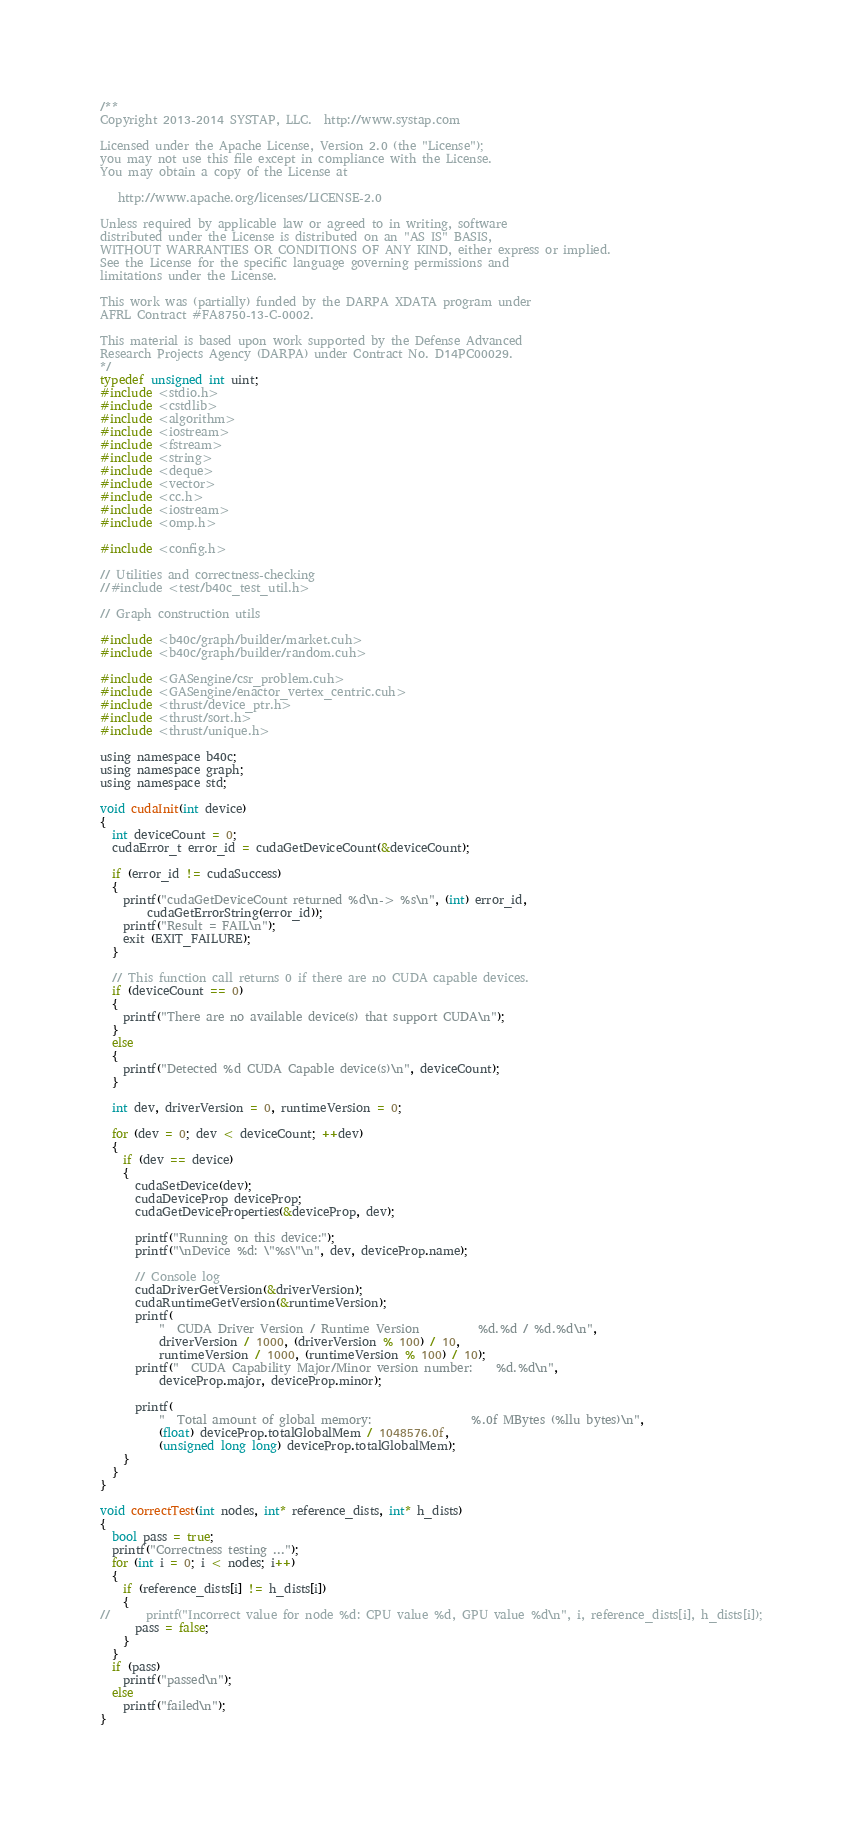Convert code to text. <code><loc_0><loc_0><loc_500><loc_500><_Cuda_>/**
Copyright 2013-2014 SYSTAP, LLC.  http://www.systap.com

Licensed under the Apache License, Version 2.0 (the "License");
you may not use this file except in compliance with the License.
You may obtain a copy of the License at

   http://www.apache.org/licenses/LICENSE-2.0

Unless required by applicable law or agreed to in writing, software
distributed under the License is distributed on an "AS IS" BASIS,
WITHOUT WARRANTIES OR CONDITIONS OF ANY KIND, either express or implied.
See the License for the specific language governing permissions and
limitations under the License.

This work was (partially) funded by the DARPA XDATA program under
AFRL Contract #FA8750-13-C-0002.

This material is based upon work supported by the Defense Advanced
Research Projects Agency (DARPA) under Contract No. D14PC00029.
*/
typedef unsigned int uint;
#include <stdio.h>
#include <cstdlib>
#include <algorithm>
#include <iostream>
#include <fstream>
#include <string>
#include <deque>
#include <vector>
#include <cc.h>
#include <iostream>
#include <omp.h>

#include <config.h>

// Utilities and correctness-checking
//#include <test/b40c_test_util.h>

// Graph construction utils

#include <b40c/graph/builder/market.cuh>
#include <b40c/graph/builder/random.cuh>

#include <GASengine/csr_problem.cuh>
#include <GASengine/enactor_vertex_centric.cuh>
#include <thrust/device_ptr.h>
#include <thrust/sort.h>
#include <thrust/unique.h>

using namespace b40c;
using namespace graph;
using namespace std;

void cudaInit(int device)
{
  int deviceCount = 0;
  cudaError_t error_id = cudaGetDeviceCount(&deviceCount);

  if (error_id != cudaSuccess)
  {
    printf("cudaGetDeviceCount returned %d\n-> %s\n", (int) error_id,
        cudaGetErrorString(error_id));
    printf("Result = FAIL\n");
    exit (EXIT_FAILURE);
  }

  // This function call returns 0 if there are no CUDA capable devices.
  if (deviceCount == 0)
  {
    printf("There are no available device(s) that support CUDA\n");
  }
  else
  {
    printf("Detected %d CUDA Capable device(s)\n", deviceCount);
  }

  int dev, driverVersion = 0, runtimeVersion = 0;

  for (dev = 0; dev < deviceCount; ++dev)
  {
    if (dev == device)
    {
      cudaSetDevice(dev);
      cudaDeviceProp deviceProp;
      cudaGetDeviceProperties(&deviceProp, dev);

      printf("Running on this device:");
      printf("\nDevice %d: \"%s\"\n", dev, deviceProp.name);

      // Console log
      cudaDriverGetVersion(&driverVersion);
      cudaRuntimeGetVersion(&runtimeVersion);
      printf(
          "  CUDA Driver Version / Runtime Version          %d.%d / %d.%d\n",
          driverVersion / 1000, (driverVersion % 100) / 10,
          runtimeVersion / 1000, (runtimeVersion % 100) / 10);
      printf("  CUDA Capability Major/Minor version number:    %d.%d\n",
          deviceProp.major, deviceProp.minor);

      printf(
          "  Total amount of global memory:                 %.0f MBytes (%llu bytes)\n",
          (float) deviceProp.totalGlobalMem / 1048576.0f,
          (unsigned long long) deviceProp.totalGlobalMem);
    }
  }
}

void correctTest(int nodes, int* reference_dists, int* h_dists)
{
  bool pass = true;
  printf("Correctness testing ...");
  for (int i = 0; i < nodes; i++)
  {
    if (reference_dists[i] != h_dists[i])
    {
//      printf("Incorrect value for node %d: CPU value %d, GPU value %d\n", i, reference_dists[i], h_dists[i]);
      pass = false;
    }
  }
  if (pass)
    printf("passed\n");
  else
    printf("failed\n");
}
</code> 